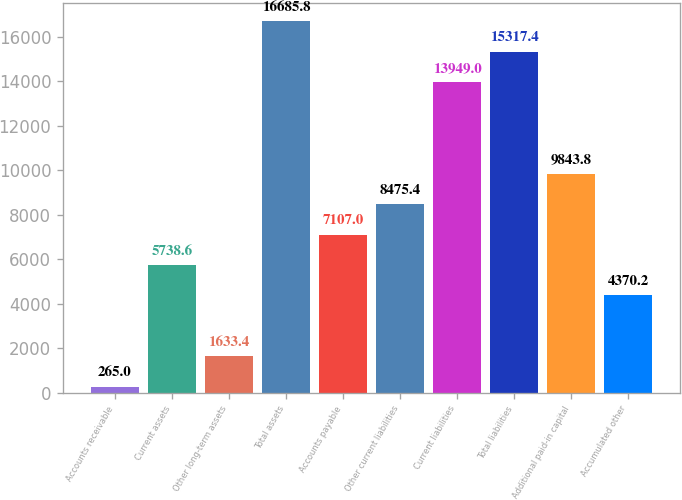Convert chart. <chart><loc_0><loc_0><loc_500><loc_500><bar_chart><fcel>Accounts receivable<fcel>Current assets<fcel>Other long-term assets<fcel>Total assets<fcel>Accounts payable<fcel>Other current liabilities<fcel>Current liabilities<fcel>Total liabilities<fcel>Additional paid-in capital<fcel>Accumulated other<nl><fcel>265<fcel>5738.6<fcel>1633.4<fcel>16685.8<fcel>7107<fcel>8475.4<fcel>13949<fcel>15317.4<fcel>9843.8<fcel>4370.2<nl></chart> 